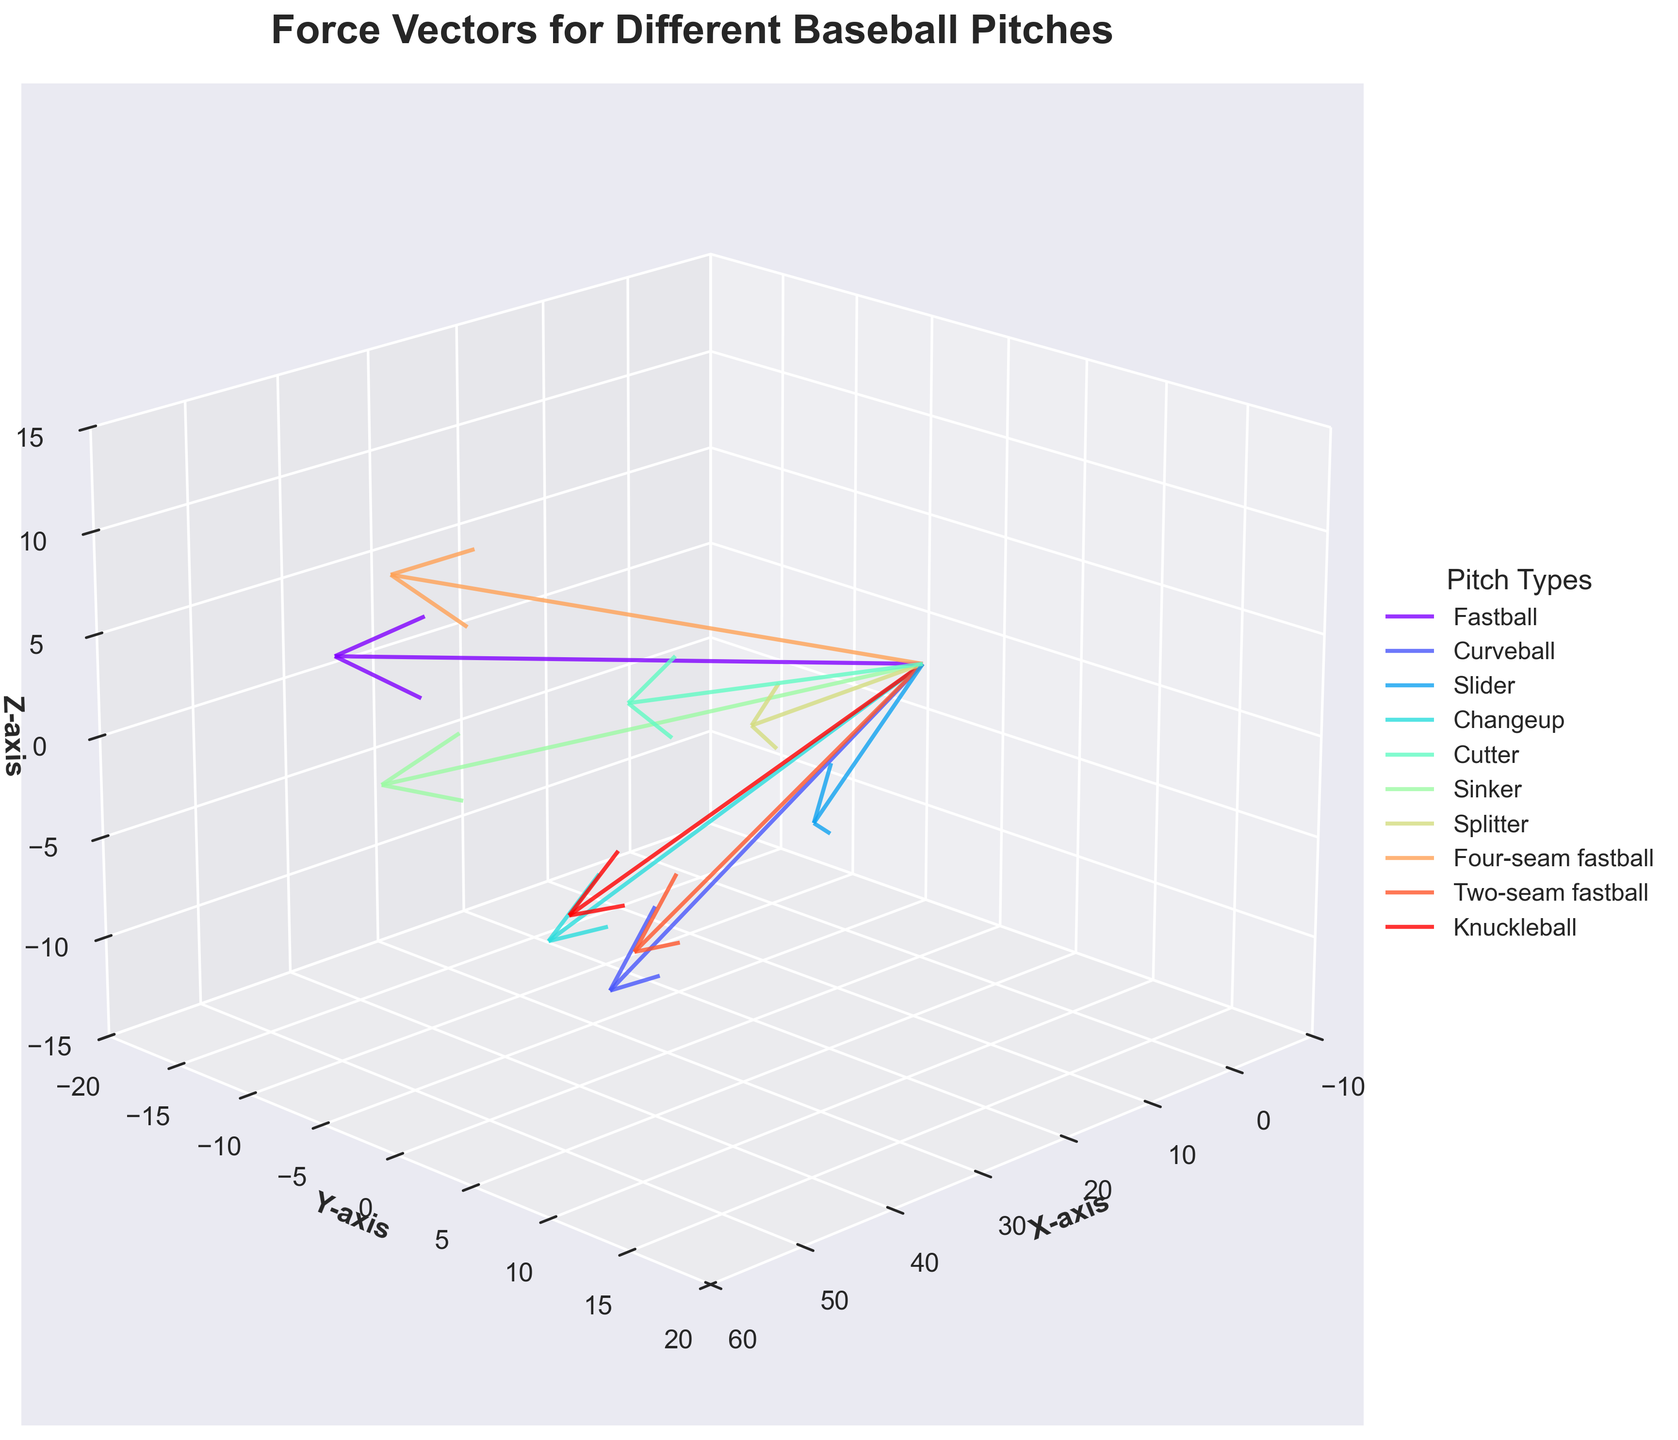How many different pitch types are shown in the plot? Look at the legend of the plot, which lists all the pitch types included in the figure. Count the number of unique entries.
Answer: 10 What is the title of the plot? The title is generally located at the top center of the plot. It is usually written in a larger font size to stand out.
Answer: Force Vectors for Different Baseball Pitches Which axis represents the force in the Y direction? Identify the axis labels on the plot. The Y-axis label will denote the vertical direction.
Answer: Y-axis Which pitch type has the largest force vector in the X direction? Examine the lengths of the vectors along the X-axis in the plot. The vector with the largest component in the positive X direction corresponds to the 'Fastball' pitch type.
Answer: Fastball Which two pitch types have the most similar force vectors in magnitude and direction? Compare the lengths, directions, and positions of all the vectors in the plot. Identify the two vectors that are most closely aligned and have similar lengths.
Answer: Slider and Splitter What is the color of the vector representing the Cutter pitch? Locate the Cutter pitch type in the legend. Match the color listed in the legend with the corresponding vector in the plot.
Answer: Dark Blue (exact color may vary by plot) How does the force vector of the Changeup compare to the Curveball in terms of direction? Compare the direction of the vectors representing Changeup and Curveball. Look at the angles and orientations of these vectors.
Answer: Changeup vector points downward, while Curveball vector angles downward and slightly to the side What is the range of the Z-axis in the plot? Look at the Z-axis labels to see the minimum and maximum values displayed.
Answer: -15 to 15 Which pitch type shows the most negative force component in the Z direction? Locate the vectors in the plot and compare their Z components. The vector with the most downward direction in the Z-axis represents the Sinker.
Answer: Sinker How are the vectors color-coded in the plot? Identify the relationship between the legend and the colors of the vectors in the plot. Each pitch type has its unique corresponding color.
Answer: By pitch type 